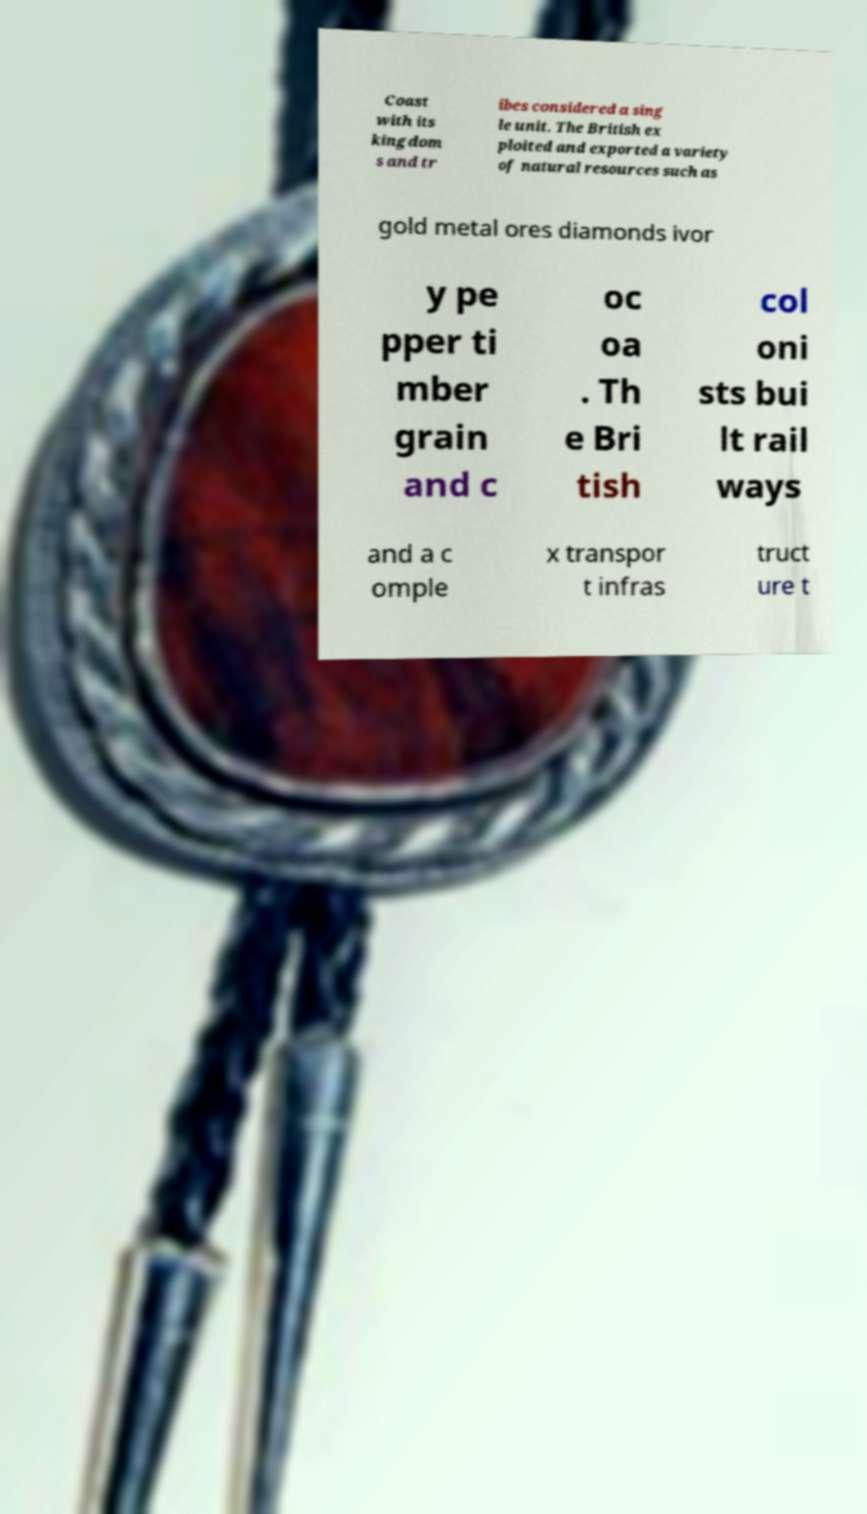Please read and relay the text visible in this image. What does it say? Coast with its kingdom s and tr ibes considered a sing le unit. The British ex ploited and exported a variety of natural resources such as gold metal ores diamonds ivor y pe pper ti mber grain and c oc oa . Th e Bri tish col oni sts bui lt rail ways and a c omple x transpor t infras truct ure t 